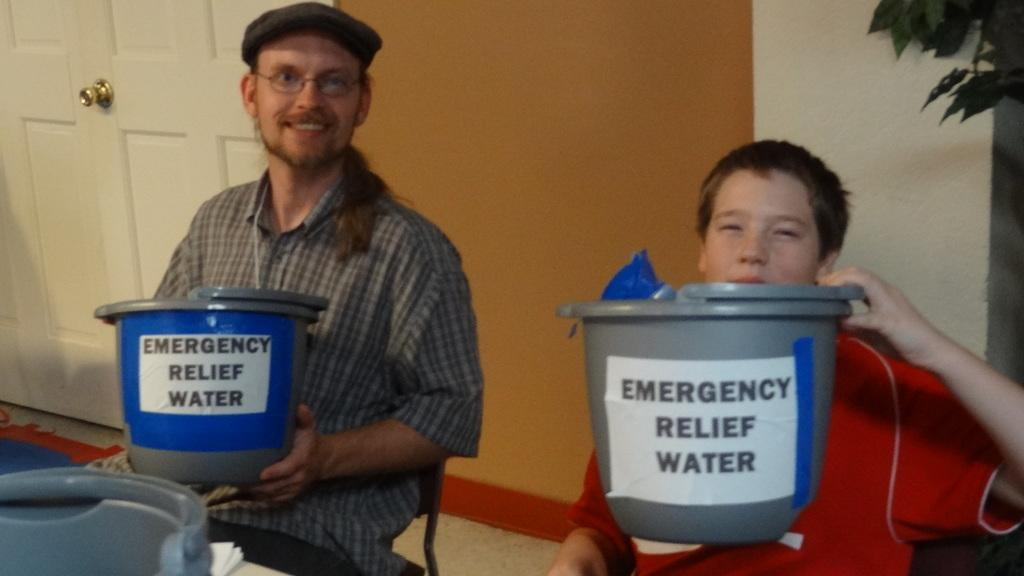<image>
Relay a brief, clear account of the picture shown. A man and a boy are holding bucks that say Emergency Relief Water. 